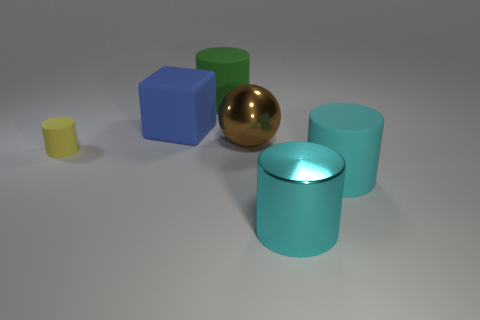Subtract 1 cylinders. How many cylinders are left? 3 Subtract all green spheres. Subtract all green cylinders. How many spheres are left? 1 Add 3 brown balls. How many objects exist? 9 Subtract all balls. How many objects are left? 5 Add 1 metallic things. How many metallic things exist? 3 Subtract 0 brown blocks. How many objects are left? 6 Subtract all big green rubber objects. Subtract all large shiny cylinders. How many objects are left? 4 Add 3 brown spheres. How many brown spheres are left? 4 